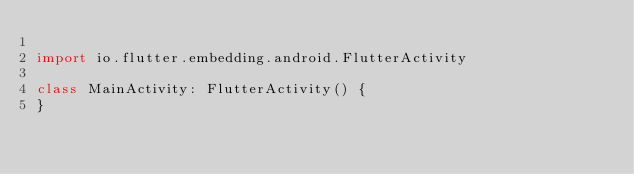<code> <loc_0><loc_0><loc_500><loc_500><_Kotlin_>
import io.flutter.embedding.android.FlutterActivity

class MainActivity: FlutterActivity() {
}
</code> 